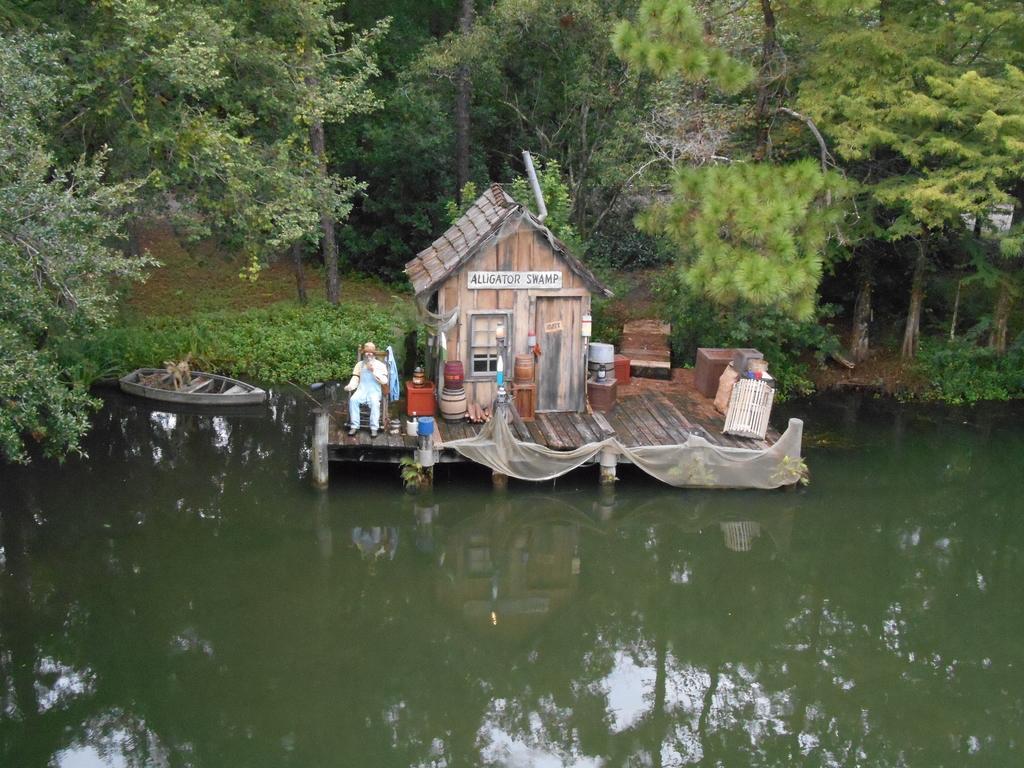Can you describe this image briefly? In the foreground of this image, there is water on the bottom. In the background, there is a house, few objects on the wooden surface and a man sitting on the chair is on the wooden surface and we can also see a boat on the water and trees on the top. 